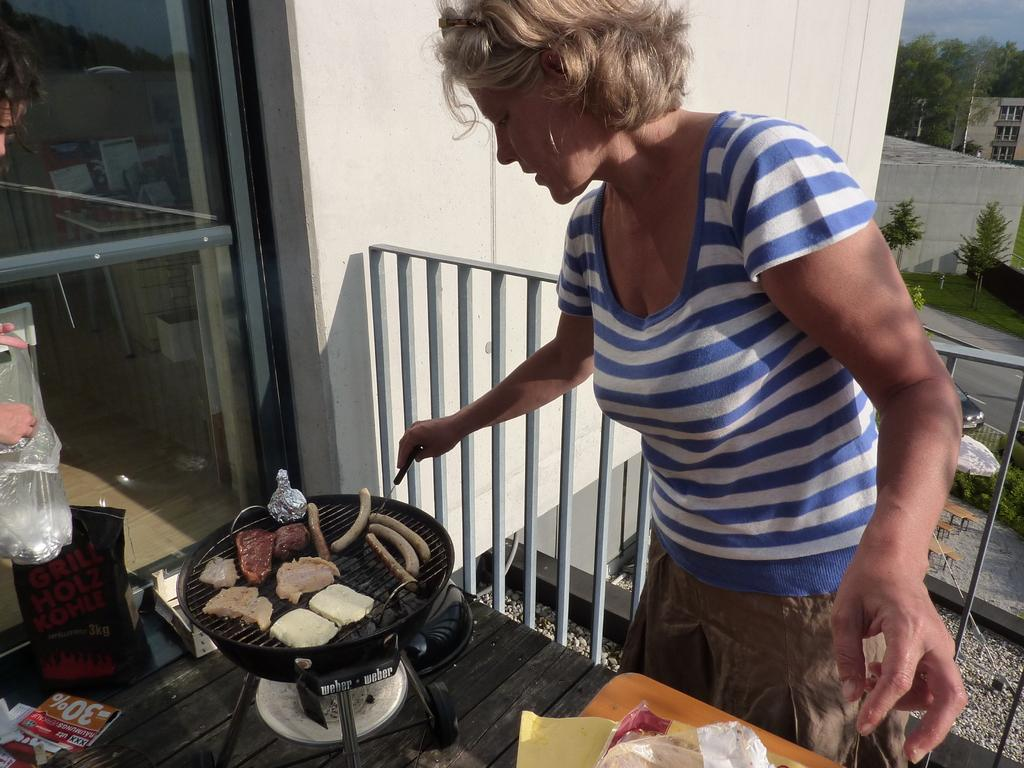<image>
Render a clear and concise summary of the photo. A woman cooks the sausages that she got 30% extra free on. 